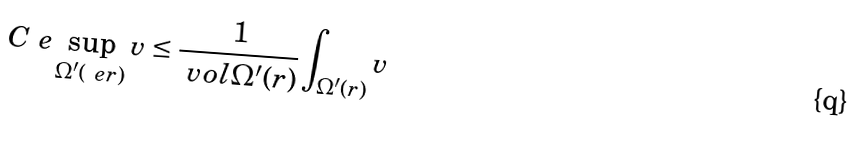<formula> <loc_0><loc_0><loc_500><loc_500>C _ { \ } e \sup _ { \Omega ^ { \prime } ( \ e r ) } v \leq \frac { 1 } { \ v o l \Omega ^ { \prime } ( r ) } \int _ { \Omega ^ { \prime } ( r ) } v</formula> 